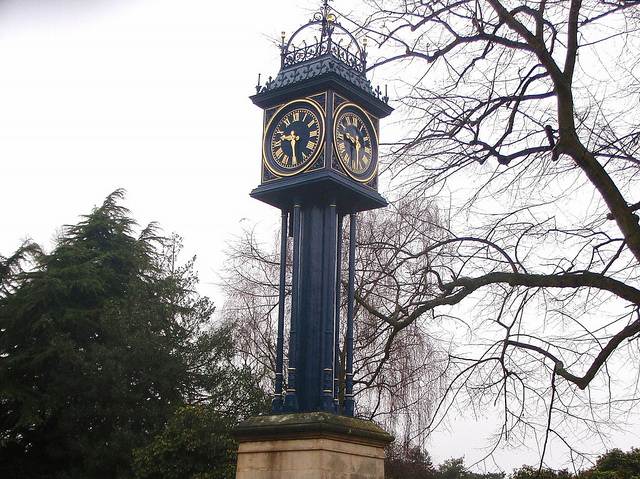Can you tell me more about the clock's architecture and style? Certainly! The clock features a Victorian Gothic style, noted for its ornate details, like the filigree on the metalwork, and the tall, slender structure. This design harks back to the mid-to-late 19th century, often associated with historical buildings and monuments of that era. 